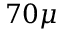Convert formula to latex. <formula><loc_0><loc_0><loc_500><loc_500>7 0 \mu</formula> 